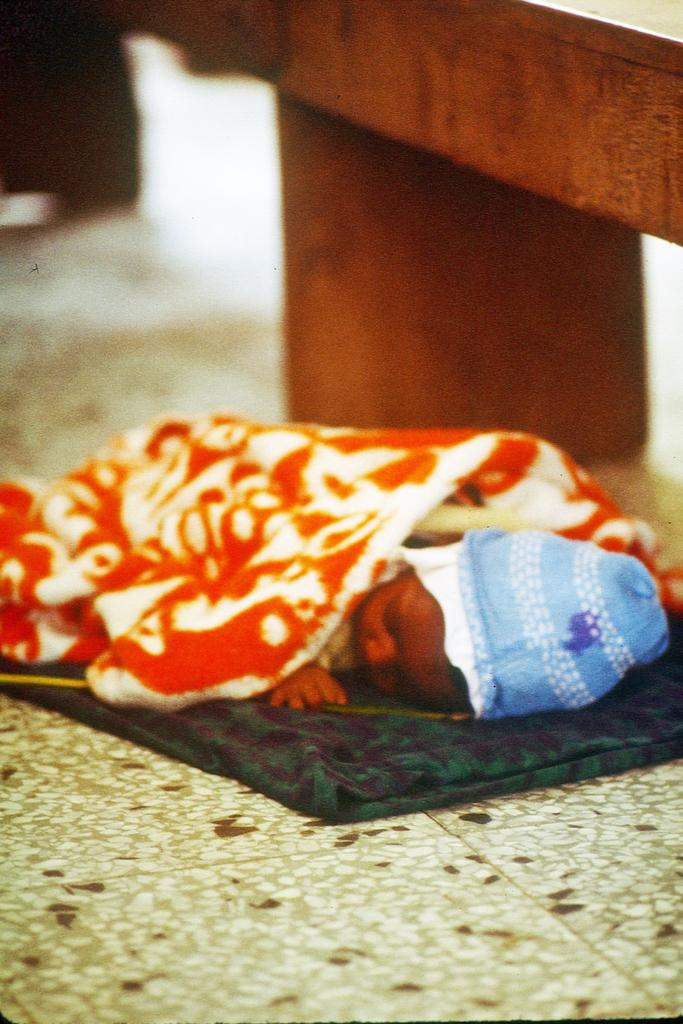What is the main subject of the picture? The main subject of the picture is a baby. What is the baby doing in the picture? The baby is laying on the floor. What is covering the baby in the picture? There is an orange color blanket on the baby. What is the baby wearing on her head? The baby is wearing a blue color cap on her head. How many people are in the crowd surrounding the baby in the image? There is no crowd present in the image; it only features a baby laying on the floor with an orange blanket and a blue cap. 